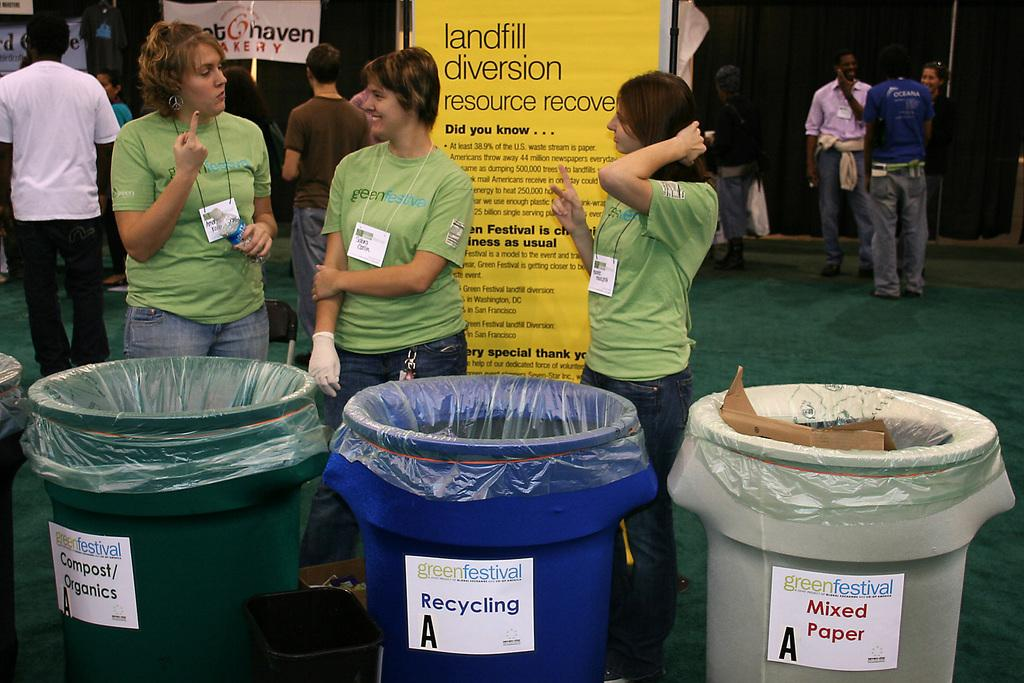<image>
Summarize the visual content of the image. Three women standing in front of different trash bins like Recycling and MIxed paper. 